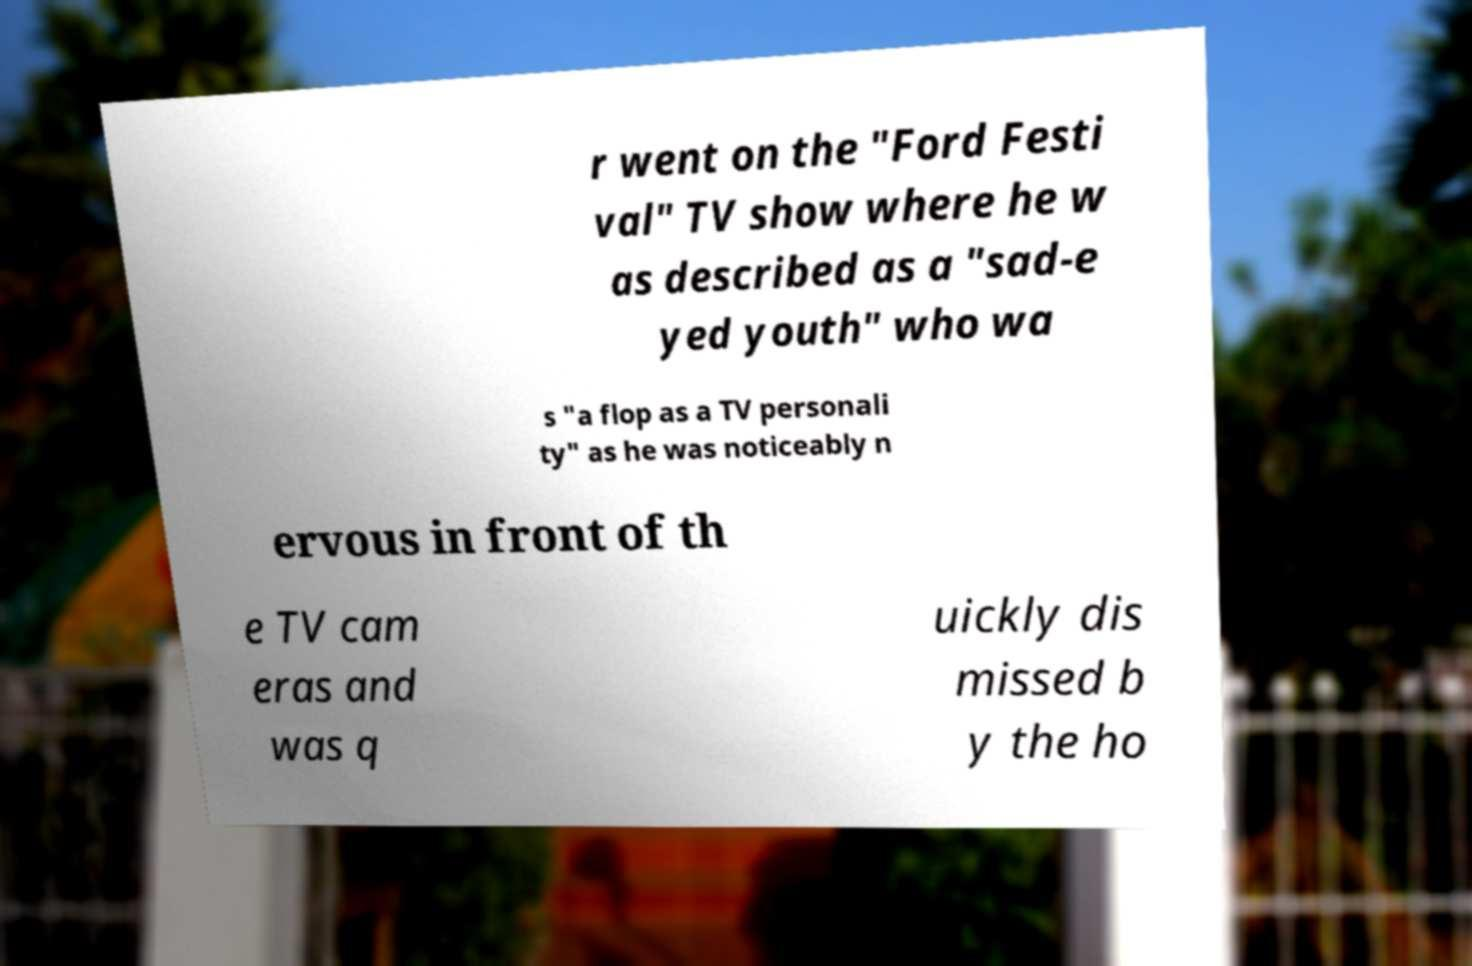Please read and relay the text visible in this image. What does it say? r went on the "Ford Festi val" TV show where he w as described as a "sad-e yed youth" who wa s "a flop as a TV personali ty" as he was noticeably n ervous in front of th e TV cam eras and was q uickly dis missed b y the ho 